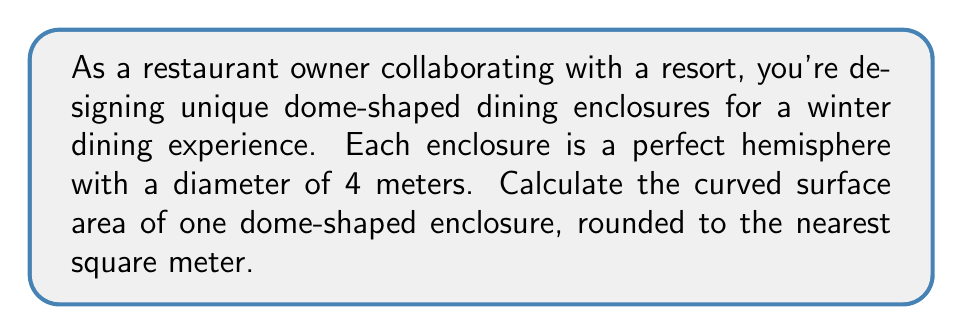Provide a solution to this math problem. To solve this problem, we'll follow these steps:

1) The formula for the curved surface area of a hemisphere is:
   $$A = 2\pi r^2$$
   where $r$ is the radius of the hemisphere.

2) We're given the diameter, which is 4 meters. The radius is half of this:
   $$r = \frac{4}{2} = 2\text{ meters}$$

3) Now, let's substitute this into our formula:
   $$A = 2\pi (2)^2$$

4) Simplify:
   $$A = 2\pi (4) = 8\pi$$

5) Calculate:
   $$A = 8 \times 3.14159... \approx 25.13\text{ m}^2$$

6) Rounding to the nearest square meter:
   $$A \approx 25\text{ m}^2$$

[asy]
import geometry;

size(200);
pair O = (0,0);
real r = 2;
draw(Circle(O,r));
draw((-r,0)--(r,0));
draw(O--(0,r),dashed);
label("r",(0,r/2),E);
label("4m",(-r,0),S);
[/asy]
Answer: 25 m² 